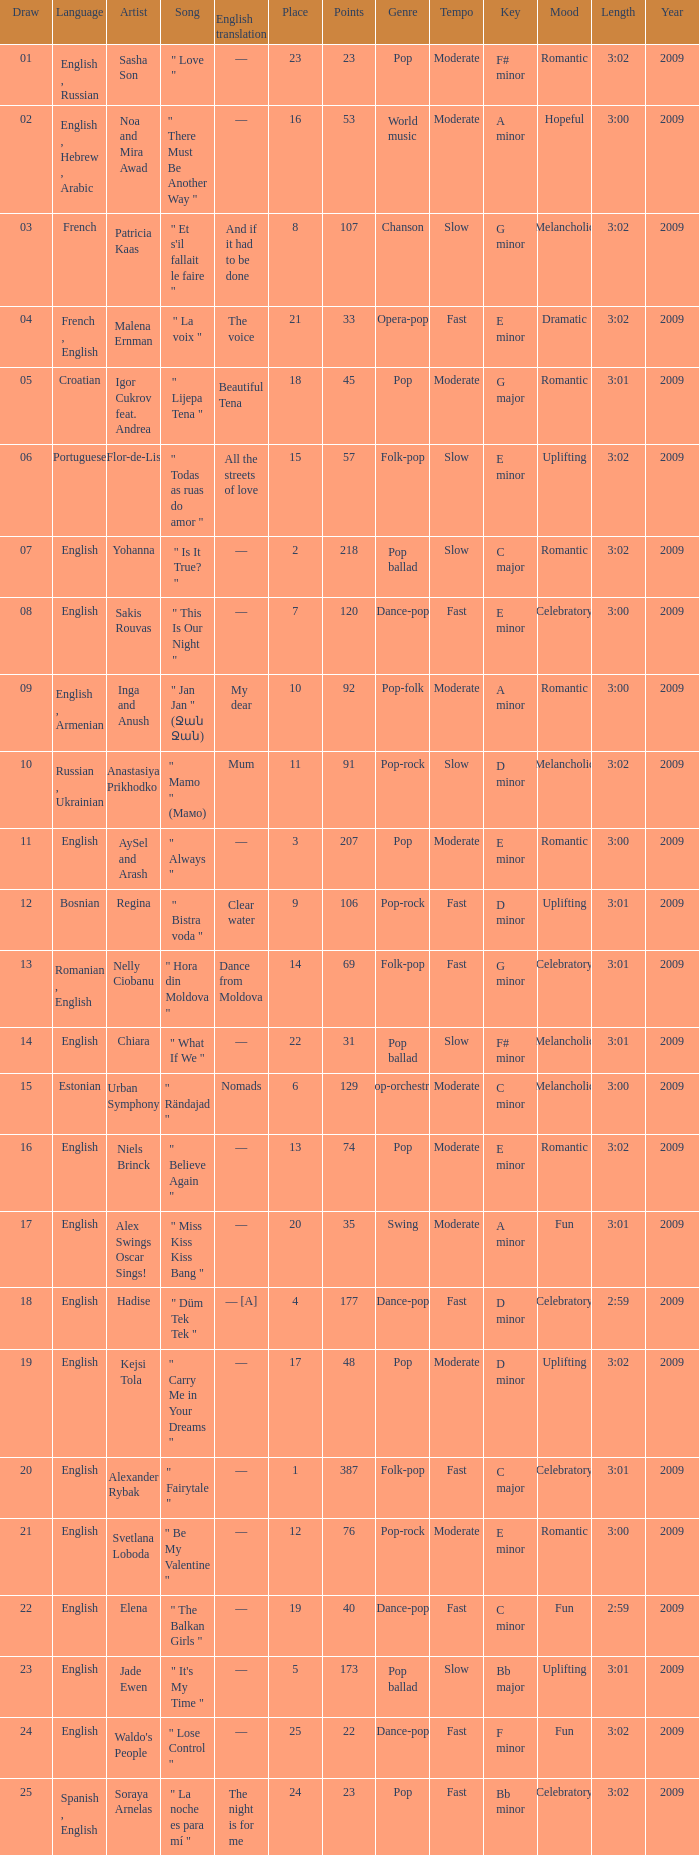What song was in french? " Et s'il fallait le faire ". 